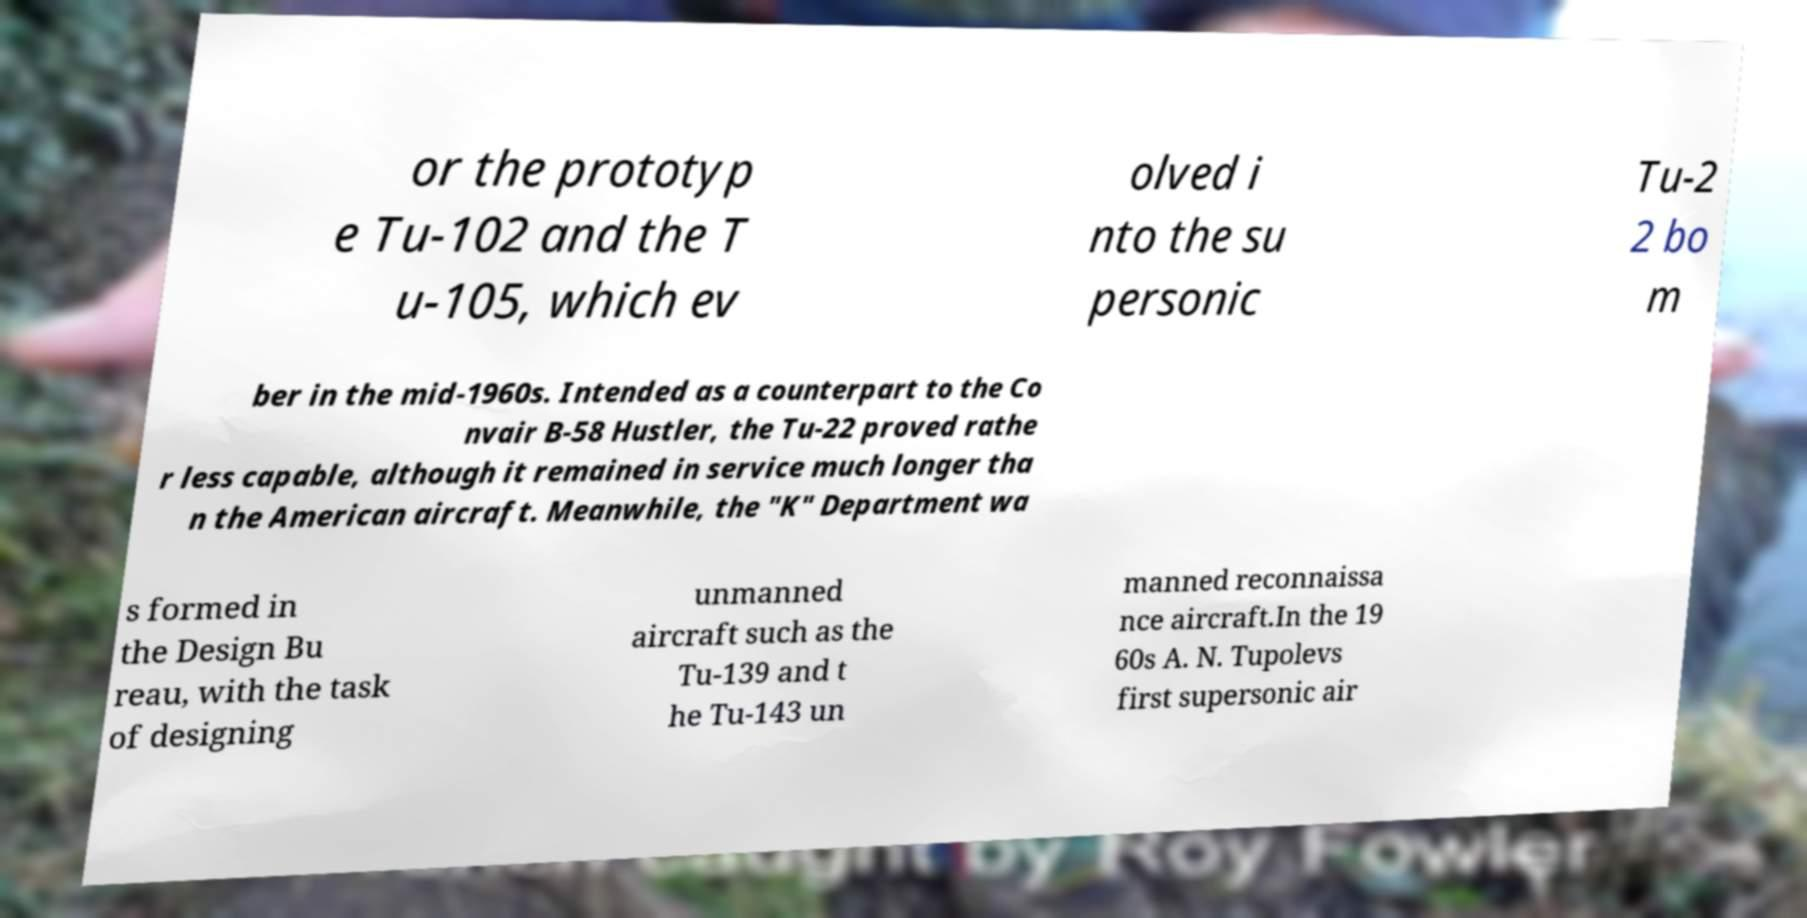Can you accurately transcribe the text from the provided image for me? or the prototyp e Tu-102 and the T u-105, which ev olved i nto the su personic Tu-2 2 bo m ber in the mid-1960s. Intended as a counterpart to the Co nvair B-58 Hustler, the Tu-22 proved rathe r less capable, although it remained in service much longer tha n the American aircraft. Meanwhile, the "K" Department wa s formed in the Design Bu reau, with the task of designing unmanned aircraft such as the Tu-139 and t he Tu-143 un manned reconnaissa nce aircraft.In the 19 60s A. N. Tupolevs first supersonic air 